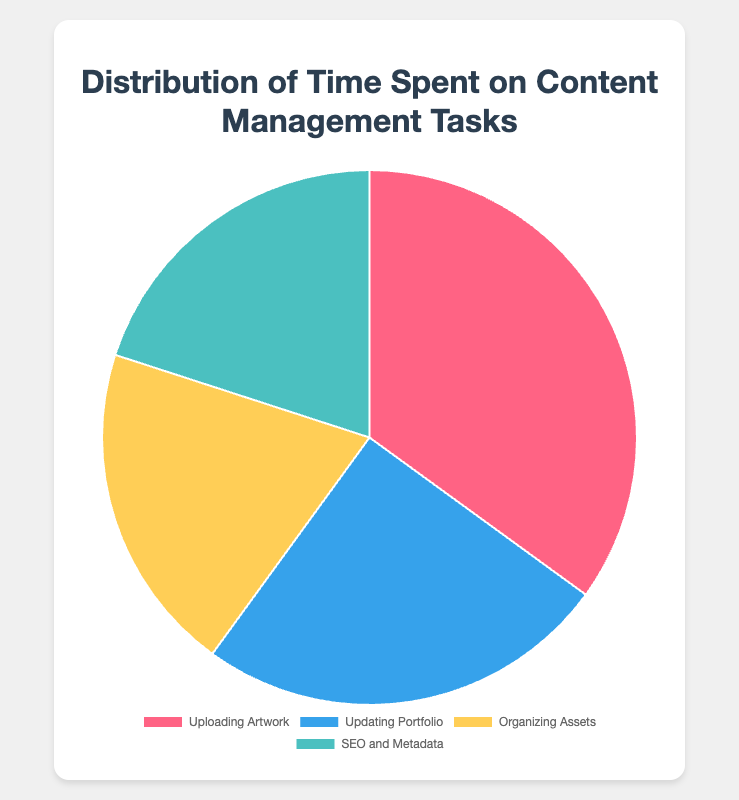What task takes up the most time in content management? From the pie chart, "Uploading Artwork" occupies the largest section.
Answer: Uploading Artwork What percentage of time is spent on tasks other than "Uploading Artwork"? Total percentage is 100%. Subtracting the 35% for "Uploading Artwork", we get 100% - 35% = 65%.
Answer: 65% Which tasks have equal time distribution? Both "Organizing Assets" and "SEO and Metadata" have a 20% time distribution, indicated by the equally sized pie sections.
Answer: Organizing Assets & SEO and Metadata What is the combined percentage of time spent on "Updating Portfolio" and "SEO and Metadata"? "Updating Portfolio" is 25% and "SEO and Metadata" is 20%, giving a total of 25% + 20% = 45%.
Answer: 45% How much more time is spent on "Uploading Artwork" compared to "Organizing Assets"? "Uploading Artwork" is 35% and "Organizing Assets" is 20%. The difference is 35% - 20% = 15%.
Answer: 15% Which section of the pie chart is represented in yellow? The yellow section of the pie chart corresponds to "Organizing Assets".
Answer: Organizing Assets If "Updating Portfolio" were increased by 5%, what would be its new percentage? "Updating Portfolio" is currently 25%. Increasing by 5% makes it 25% + 5% = 30%.
Answer: 30% What colors are used for the tasks "SEO and Metadata" and "Uploading Artwork"? "SEO and Metadata" is represented in green and "Uploading Artwork" is in red.
Answer: Red and Green Which task takes up less than a quarter of the total time but more than a tenth? Both "Organizing Assets" and "SEO and Metadata" fall into this range with each taking up 20% of the total time.
Answer: Organizing Assets & SEO and Metadata What is the average percentage of time spent on "Organizing Assets" and "SEO and Metadata"? Both tasks have 20% each. The average is (20% + 20%)/2 = 20%.
Answer: 20% 